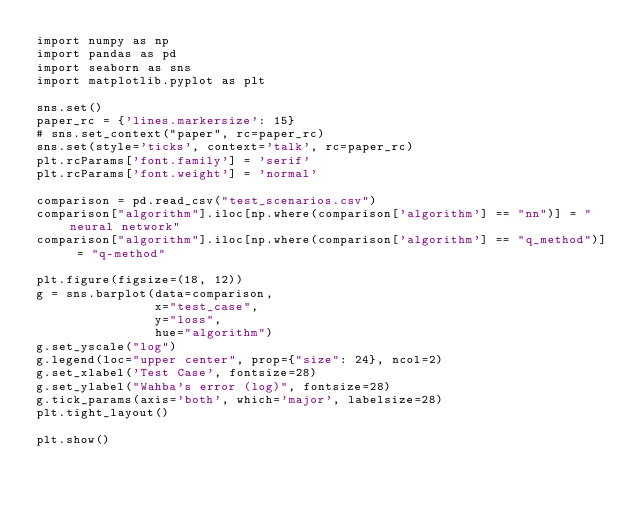Convert code to text. <code><loc_0><loc_0><loc_500><loc_500><_Python_>import numpy as np
import pandas as pd
import seaborn as sns
import matplotlib.pyplot as plt

sns.set()
paper_rc = {'lines.markersize': 15}
# sns.set_context("paper", rc=paper_rc)
sns.set(style='ticks', context='talk', rc=paper_rc)
plt.rcParams['font.family'] = 'serif'
plt.rcParams['font.weight'] = 'normal'

comparison = pd.read_csv("test_scenarios.csv")
comparison["algorithm"].iloc[np.where(comparison['algorithm'] == "nn")] = "neural network"
comparison["algorithm"].iloc[np.where(comparison['algorithm'] == "q_method")] = "q-method"

plt.figure(figsize=(18, 12))
g = sns.barplot(data=comparison,
                x="test_case",
                y="loss",
                hue="algorithm")
g.set_yscale("log")
g.legend(loc="upper center", prop={"size": 24}, ncol=2)
g.set_xlabel('Test Case', fontsize=28)
g.set_ylabel("Wahba's error (log)", fontsize=28)
g.tick_params(axis='both', which='major', labelsize=28)
plt.tight_layout()

plt.show()
</code> 